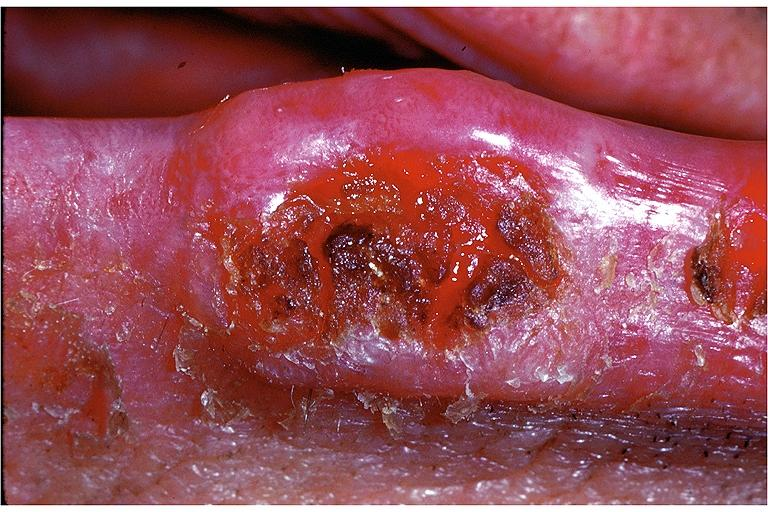what does this image show?
Answer the question using a single word or phrase. Squamous cell carcinoma 